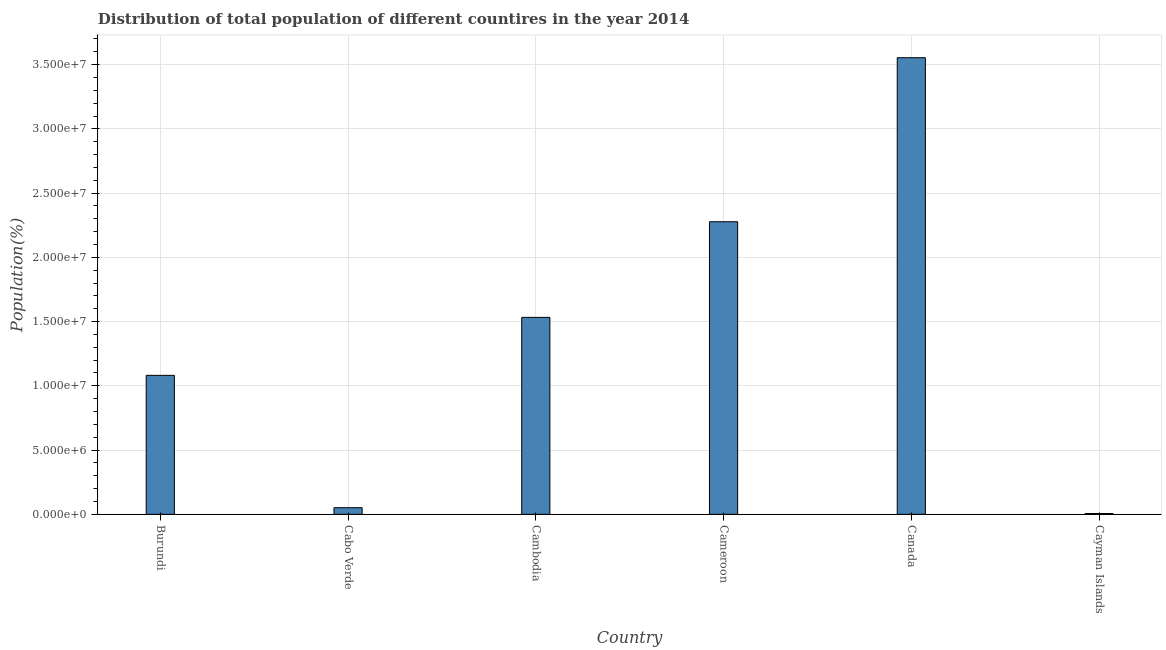Does the graph contain any zero values?
Keep it short and to the point. No. Does the graph contain grids?
Your response must be concise. Yes. What is the title of the graph?
Your answer should be compact. Distribution of total population of different countires in the year 2014. What is the label or title of the Y-axis?
Your answer should be very brief. Population(%). What is the population in Cayman Islands?
Give a very brief answer. 5.92e+04. Across all countries, what is the maximum population?
Offer a terse response. 3.55e+07. Across all countries, what is the minimum population?
Provide a succinct answer. 5.92e+04. In which country was the population minimum?
Your response must be concise. Cayman Islands. What is the sum of the population?
Offer a terse response. 8.50e+07. What is the difference between the population in Burundi and Cayman Islands?
Your answer should be compact. 1.08e+07. What is the average population per country?
Ensure brevity in your answer.  1.42e+07. What is the median population?
Make the answer very short. 1.31e+07. What is the ratio of the population in Burundi to that in Canada?
Offer a terse response. 0.3. Is the population in Cabo Verde less than that in Cambodia?
Keep it short and to the point. Yes. Is the difference between the population in Burundi and Cameroon greater than the difference between any two countries?
Your answer should be compact. No. What is the difference between the highest and the second highest population?
Give a very brief answer. 1.28e+07. What is the difference between the highest and the lowest population?
Your answer should be compact. 3.55e+07. How many bars are there?
Provide a succinct answer. 6. How many countries are there in the graph?
Ensure brevity in your answer.  6. Are the values on the major ticks of Y-axis written in scientific E-notation?
Your answer should be compact. Yes. What is the Population(%) of Burundi?
Your response must be concise. 1.08e+07. What is the Population(%) in Cabo Verde?
Your answer should be compact. 5.14e+05. What is the Population(%) of Cambodia?
Make the answer very short. 1.53e+07. What is the Population(%) in Cameroon?
Make the answer very short. 2.28e+07. What is the Population(%) in Canada?
Make the answer very short. 3.55e+07. What is the Population(%) of Cayman Islands?
Give a very brief answer. 5.92e+04. What is the difference between the Population(%) in Burundi and Cabo Verde?
Keep it short and to the point. 1.03e+07. What is the difference between the Population(%) in Burundi and Cambodia?
Offer a terse response. -4.51e+06. What is the difference between the Population(%) in Burundi and Cameroon?
Provide a succinct answer. -1.20e+07. What is the difference between the Population(%) in Burundi and Canada?
Your answer should be compact. -2.47e+07. What is the difference between the Population(%) in Burundi and Cayman Islands?
Ensure brevity in your answer.  1.08e+07. What is the difference between the Population(%) in Cabo Verde and Cambodia?
Your answer should be very brief. -1.48e+07. What is the difference between the Population(%) in Cabo Verde and Cameroon?
Your answer should be very brief. -2.23e+07. What is the difference between the Population(%) in Cabo Verde and Canada?
Your response must be concise. -3.50e+07. What is the difference between the Population(%) in Cabo Verde and Cayman Islands?
Keep it short and to the point. 4.55e+05. What is the difference between the Population(%) in Cambodia and Cameroon?
Offer a terse response. -7.44e+06. What is the difference between the Population(%) in Cambodia and Canada?
Your response must be concise. -2.02e+07. What is the difference between the Population(%) in Cambodia and Cayman Islands?
Give a very brief answer. 1.53e+07. What is the difference between the Population(%) in Cameroon and Canada?
Ensure brevity in your answer.  -1.28e+07. What is the difference between the Population(%) in Cameroon and Cayman Islands?
Keep it short and to the point. 2.27e+07. What is the difference between the Population(%) in Canada and Cayman Islands?
Your answer should be very brief. 3.55e+07. What is the ratio of the Population(%) in Burundi to that in Cabo Verde?
Your response must be concise. 21.05. What is the ratio of the Population(%) in Burundi to that in Cambodia?
Give a very brief answer. 0.71. What is the ratio of the Population(%) in Burundi to that in Cameroon?
Your response must be concise. 0.47. What is the ratio of the Population(%) in Burundi to that in Canada?
Provide a succinct answer. 0.3. What is the ratio of the Population(%) in Burundi to that in Cayman Islands?
Your answer should be compact. 182.8. What is the ratio of the Population(%) in Cabo Verde to that in Cambodia?
Give a very brief answer. 0.03. What is the ratio of the Population(%) in Cabo Verde to that in Cameroon?
Keep it short and to the point. 0.02. What is the ratio of the Population(%) in Cabo Verde to that in Canada?
Your response must be concise. 0.01. What is the ratio of the Population(%) in Cabo Verde to that in Cayman Islands?
Ensure brevity in your answer.  8.69. What is the ratio of the Population(%) in Cambodia to that in Cameroon?
Your response must be concise. 0.67. What is the ratio of the Population(%) in Cambodia to that in Canada?
Your answer should be compact. 0.43. What is the ratio of the Population(%) in Cambodia to that in Cayman Islands?
Give a very brief answer. 259.04. What is the ratio of the Population(%) in Cameroon to that in Canada?
Make the answer very short. 0.64. What is the ratio of the Population(%) in Cameroon to that in Cayman Islands?
Provide a succinct answer. 384.86. What is the ratio of the Population(%) in Canada to that in Cayman Islands?
Ensure brevity in your answer.  600.63. 